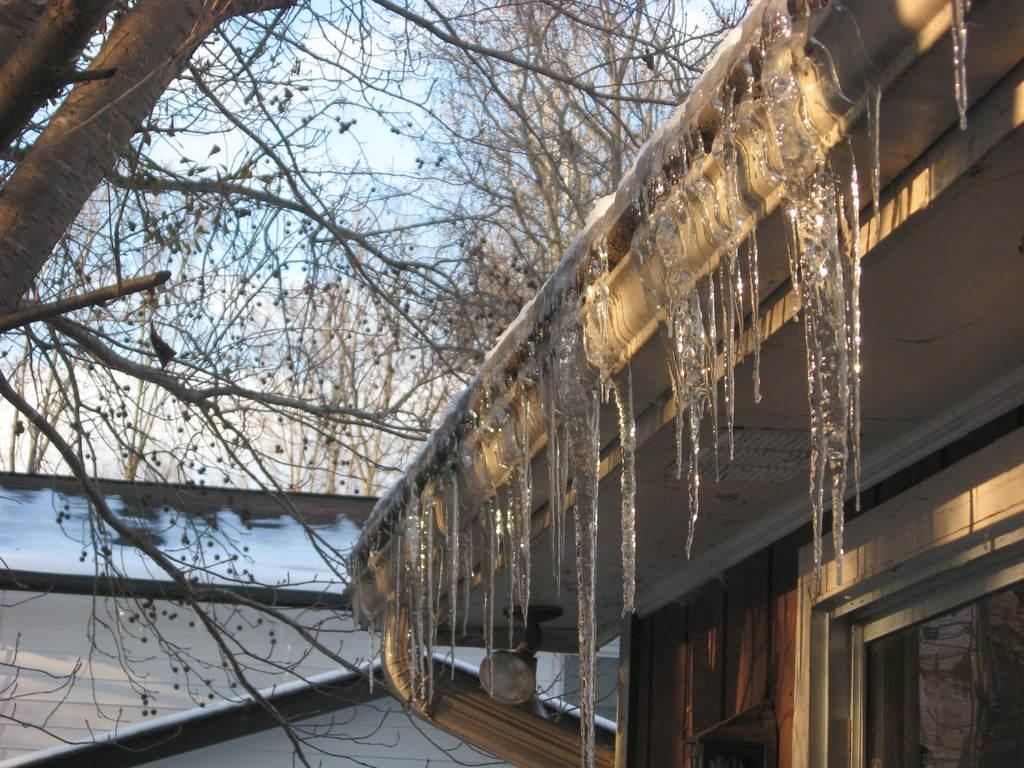What type of structures can be seen in the image? There are buildings in the image. What natural element is present in the image? There is a tree in the image. What is the source of illumination in the image? There is a light source in the image. What can be seen in the background of the image? The sky is visible in the image. What role does the father play in the image? There is no reference to a father or any people in the image, so it is not possible to answer that question. 